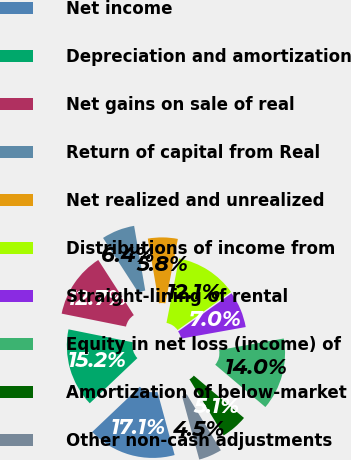Convert chart to OTSL. <chart><loc_0><loc_0><loc_500><loc_500><pie_chart><fcel>Net income<fcel>Depreciation and amortization<fcel>Net gains on sale of real<fcel>Return of capital from Real<fcel>Net realized and unrealized<fcel>Distributions of income from<fcel>Straight-lining of rental<fcel>Equity in net loss (income) of<fcel>Amortization of below-market<fcel>Other non-cash adjustments<nl><fcel>17.14%<fcel>15.25%<fcel>12.72%<fcel>6.4%<fcel>5.77%<fcel>12.09%<fcel>7.03%<fcel>13.98%<fcel>5.13%<fcel>4.5%<nl></chart> 